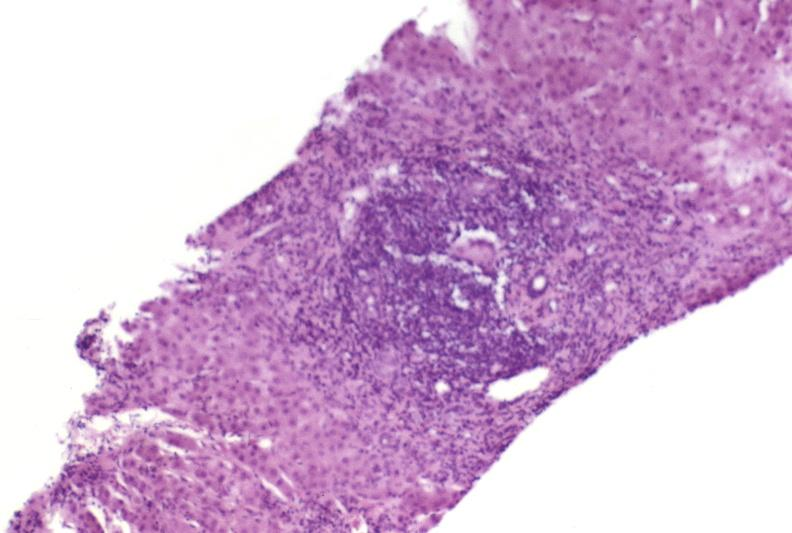s hepatobiliary present?
Answer the question using a single word or phrase. Yes 